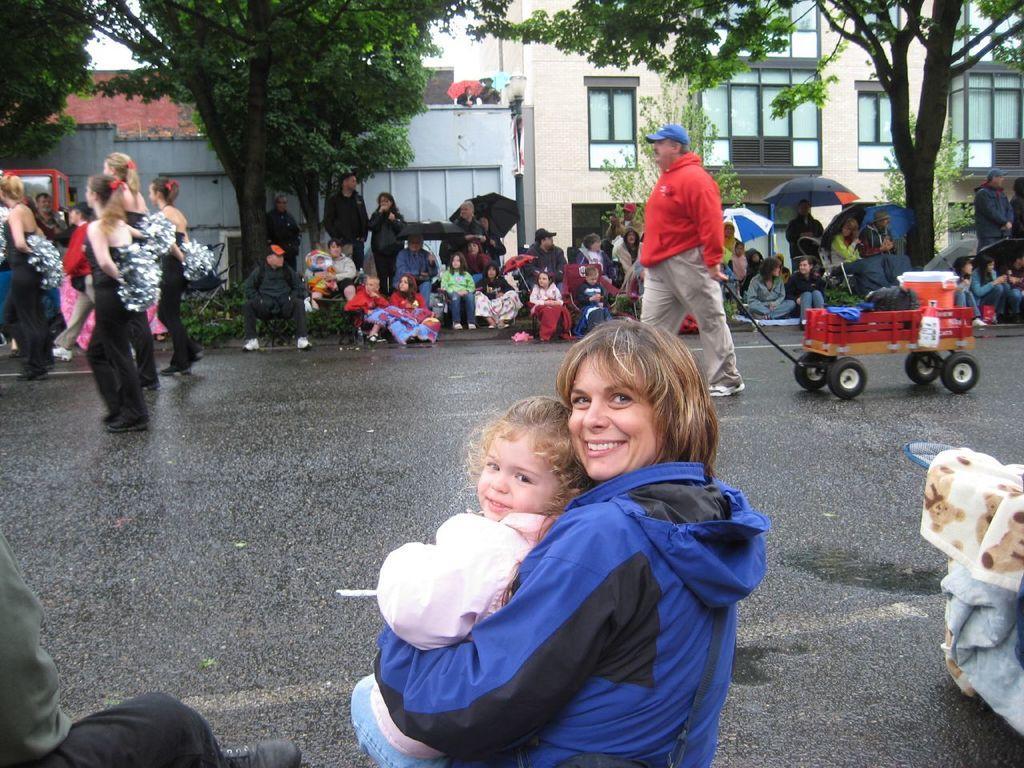Could you give a brief overview of what you see in this image? In this image people are sitting on either side of the road, in the middle a man is walking with a small truck, in the background there are trees and houses. 